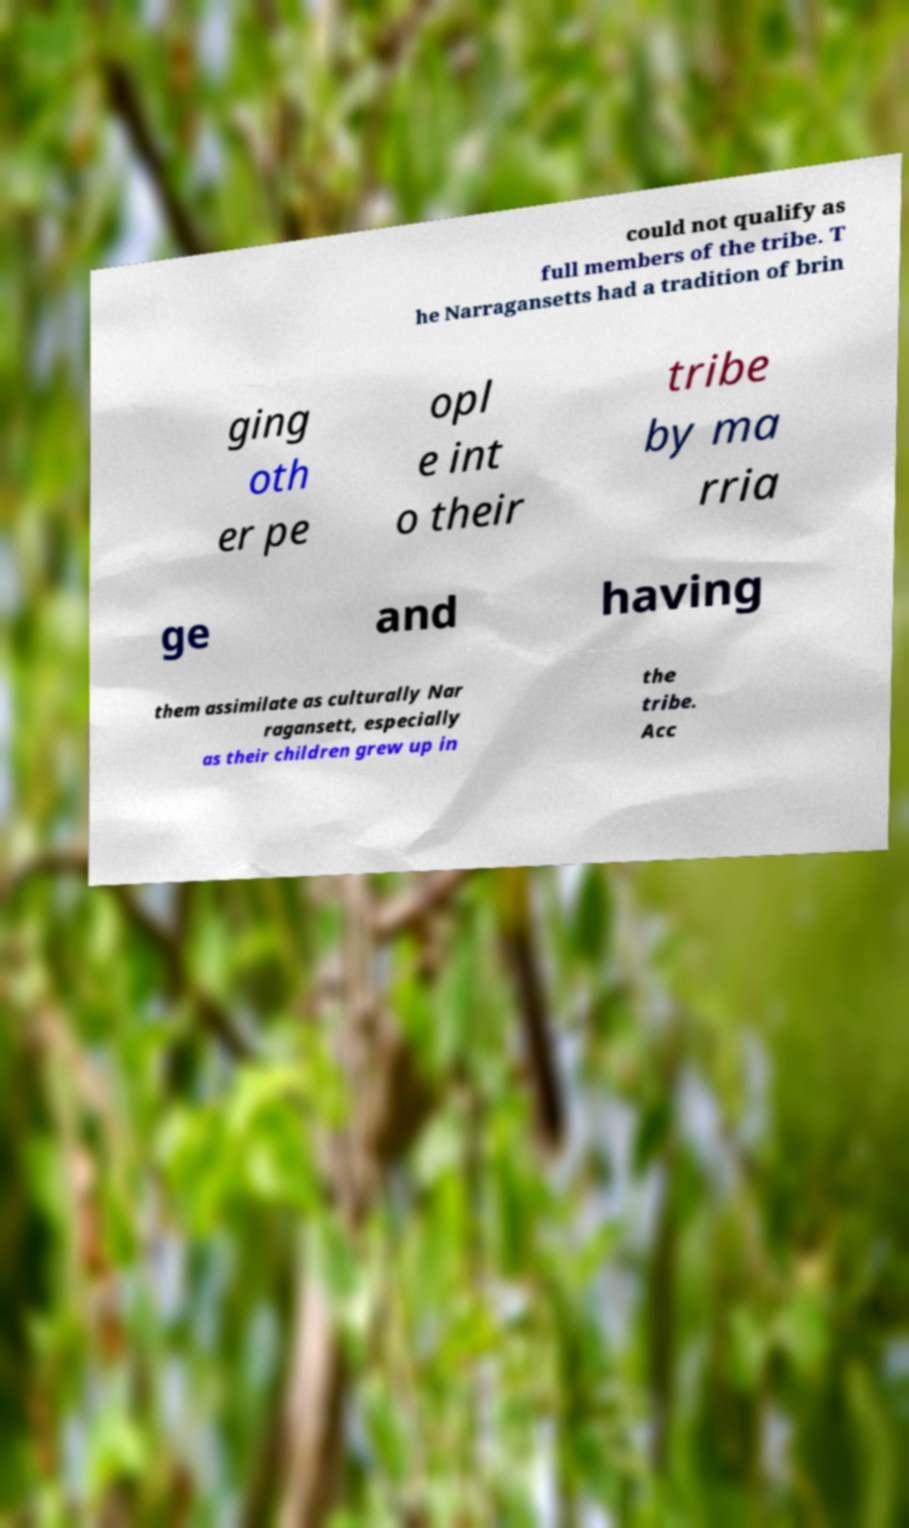Can you accurately transcribe the text from the provided image for me? could not qualify as full members of the tribe. T he Narragansetts had a tradition of brin ging oth er pe opl e int o their tribe by ma rria ge and having them assimilate as culturally Nar ragansett, especially as their children grew up in the tribe. Acc 